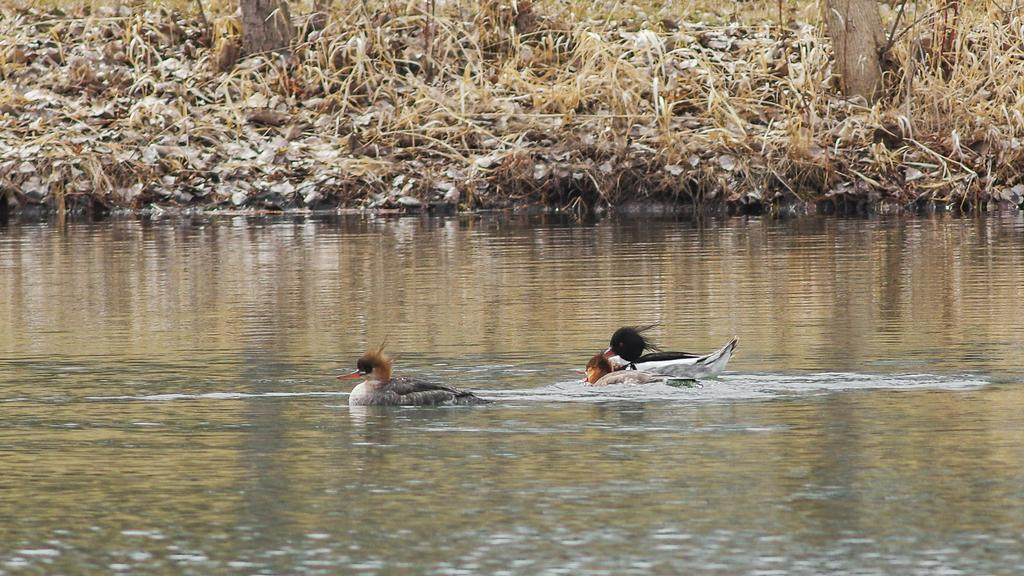How many ducks can be seen in the image? There are two ducks in the image. What are the ducks doing in the image? The ducks are swimming in the water. What else can be seen in the image besides the ducks? There are dried leaves and trees in the image. What type of legal advice is the duck on the left seeking in the image? There is no indication in the image that the ducks are seeking legal advice or interacting with a lawyer. 